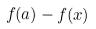Convert formula to latex. <formula><loc_0><loc_0><loc_500><loc_500>f ( a ) - f ( x )</formula> 